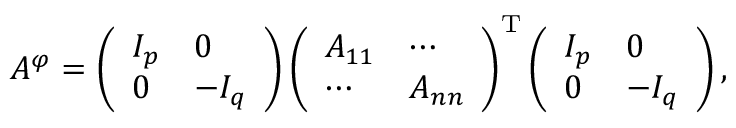<formula> <loc_0><loc_0><loc_500><loc_500>A ^ { \varphi } = \left ( { \begin{array} { l l } { I _ { p } } & { 0 } \\ { 0 } & { - I _ { q } } \end{array} } \right ) \left ( { \begin{array} { l l } { A _ { 1 1 } } & { \cdots } \\ { \cdots } & { A _ { n n } } \end{array} } \right ) ^ { T } \left ( { \begin{array} { l l } { I _ { p } } & { 0 } \\ { 0 } & { - I _ { q } } \end{array} } \right ) ,</formula> 